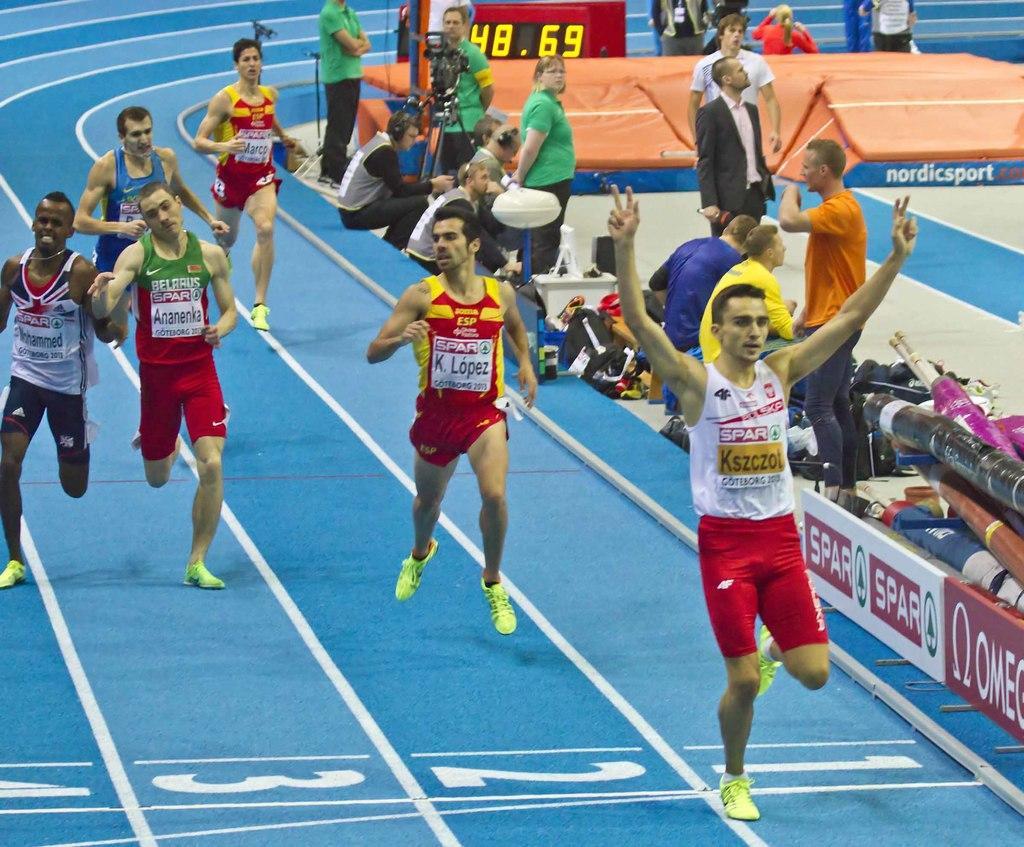Could you give a brief overview of what you see in this image? This is a track and field. Here I can see few men wearing t-shirts, shorts, shoes and running. In the background few people are standing and few people are sitting. There is a camera stand. There are few bags and some other objects are placed on the ground. 